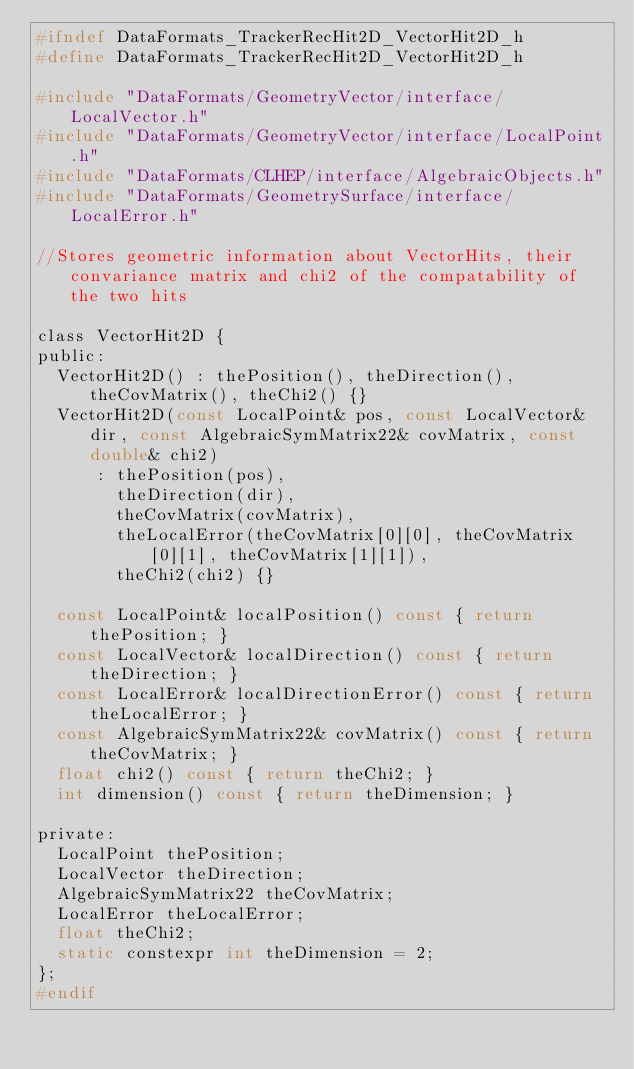Convert code to text. <code><loc_0><loc_0><loc_500><loc_500><_C_>#ifndef DataFormats_TrackerRecHit2D_VectorHit2D_h
#define DataFormats_TrackerRecHit2D_VectorHit2D_h

#include "DataFormats/GeometryVector/interface/LocalVector.h"
#include "DataFormats/GeometryVector/interface/LocalPoint.h"
#include "DataFormats/CLHEP/interface/AlgebraicObjects.h"
#include "DataFormats/GeometrySurface/interface/LocalError.h"

//Stores geometric information about VectorHits, their convariance matrix and chi2 of the compatability of the two hits

class VectorHit2D {
public:
  VectorHit2D() : thePosition(), theDirection(), theCovMatrix(), theChi2() {}
  VectorHit2D(const LocalPoint& pos, const LocalVector& dir, const AlgebraicSymMatrix22& covMatrix, const double& chi2)
      : thePosition(pos),
        theDirection(dir),
        theCovMatrix(covMatrix),
        theLocalError(theCovMatrix[0][0], theCovMatrix[0][1], theCovMatrix[1][1]),
        theChi2(chi2) {}

  const LocalPoint& localPosition() const { return thePosition; }
  const LocalVector& localDirection() const { return theDirection; }
  const LocalError& localDirectionError() const { return theLocalError; }
  const AlgebraicSymMatrix22& covMatrix() const { return theCovMatrix; }
  float chi2() const { return theChi2; }
  int dimension() const { return theDimension; }

private:
  LocalPoint thePosition;
  LocalVector theDirection;
  AlgebraicSymMatrix22 theCovMatrix;
  LocalError theLocalError;
  float theChi2;
  static constexpr int theDimension = 2;
};
#endif
</code> 